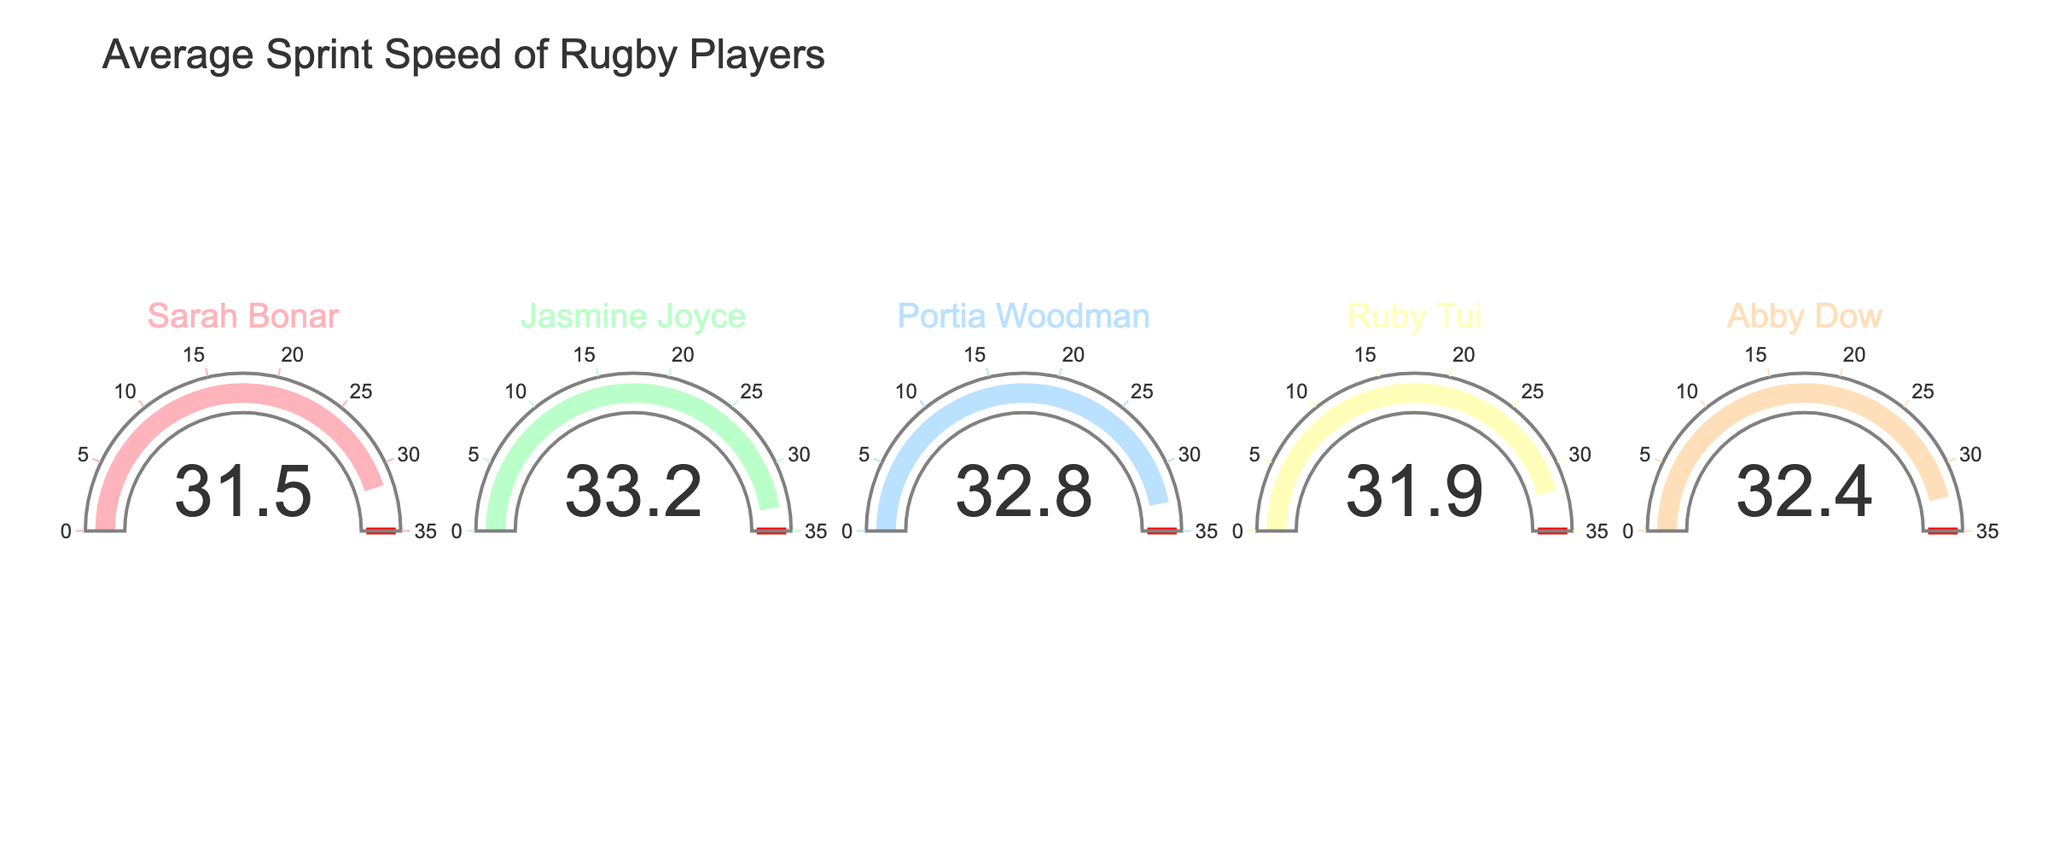How many rugby players are displayed in the figure? Count the number of gauge charts present in the figure; each represents one rugby player.
Answer: 5 Who has the highest average sprint speed among the rugby players? Identify the highest number on the gauge charts and note the corresponding player's name. Jasmine Joyce has the highest speed at 33.2 km/h.
Answer: Jasmine Joyce What is the title of the graph? Look for the text at the top of the figure which generally describes what the figure is about. The title is "Average Sprint Speed of Rugby Players".
Answer: Average Sprint Speed of Rugby Players What is the average sprint speed of Ruby Tui? Find the gauge chart labeled "Ruby Tui" and look at the number displayed. Ruby Tui's speed is 31.9 km/h.
Answer: 31.9 km/h Is there any player with a sprint speed less than 32 km/h? Check the numbers on each gauge chart to see if any value is below 32 km/h. Both Sarah Bonar and Ruby Tui have speeds less than 32 km/h.
Answer: Yes How much faster is Jasmine Joyce compared to Sarah Bonar? Subtract Sarah Bonar's sprint speed from Jasmine Joyce's sprint speed: 33.2 - 31.5. Jasmine Joyce is 1.7 km/h faster than Sarah Bonar.
Answer: 1.7 km/h What is the average sprint speed of all players combined? Sum all the players' speeds and divide by the number of players: (31.5 + 33.2 + 32.8 + 31.9 + 32.4) / 5. The combined average sprint speed is 32.36 km/h.
Answer: 32.36 km/h Which players have a sprint speed between 32 km/h and 33 km/h? Look for players whose speeds fall within the specified range. Both Portia Woodman (32.8 km/h) and Abby Dow (32.4 km/h) fall in this range.
Answer: Portia Woodman and Abby Dow What is the difference between the fastest and the slowest sprint speeds? Identify the highest and lowest speeds from the chart and subtract the lowest from the highest: 33.2 - 31.5. The difference is 1.7 km/h.
Answer: 1.7 km/h 